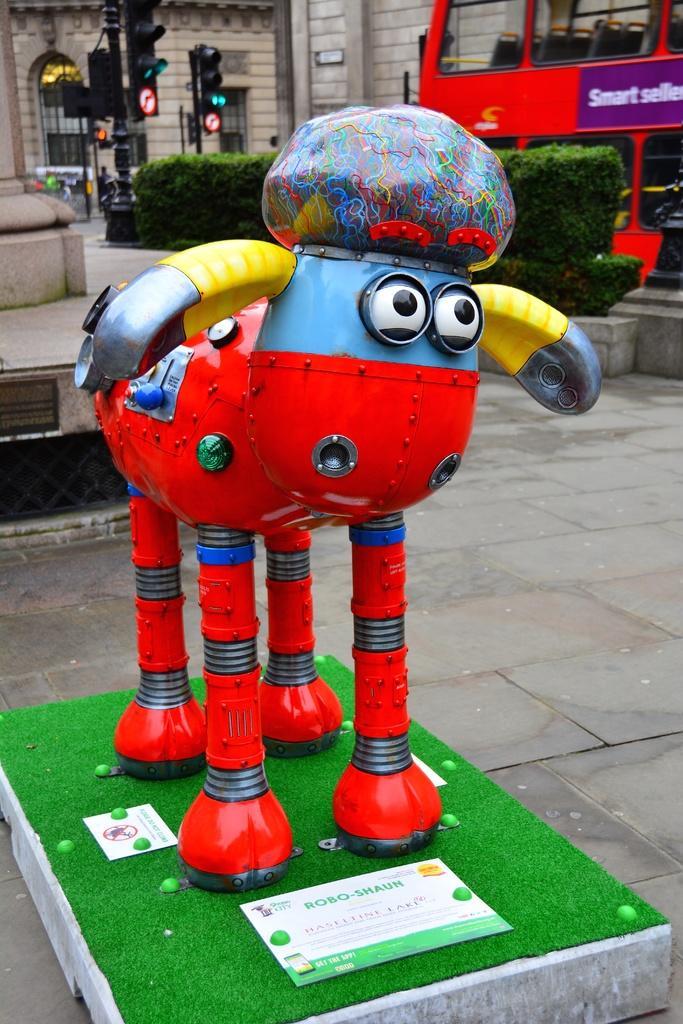Please provide a concise description of this image. There is a red color object on a greenery surface and there is a double decker bus in the right corner and there are traffic signals and a building in the background. 